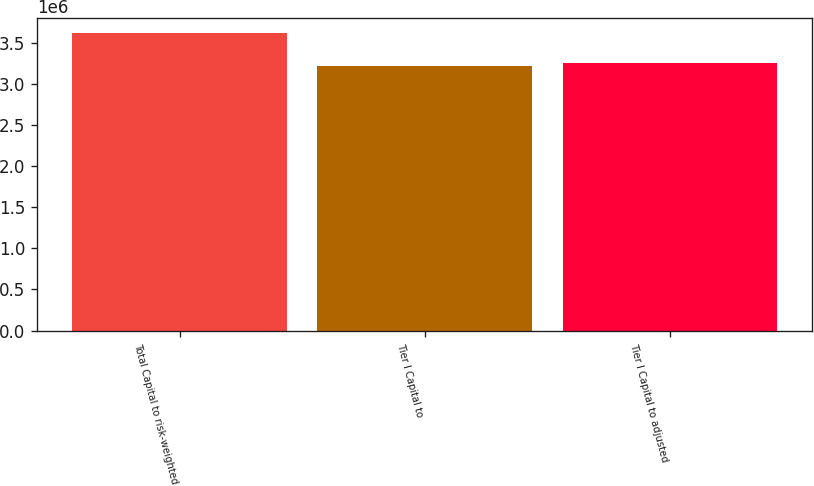<chart> <loc_0><loc_0><loc_500><loc_500><bar_chart><fcel>Total Capital to risk-weighted<fcel>Tier I Capital to<fcel>Tier I Capital to adjusted<nl><fcel>3.61845e+06<fcel>3.21918e+06<fcel>3.2591e+06<nl></chart> 